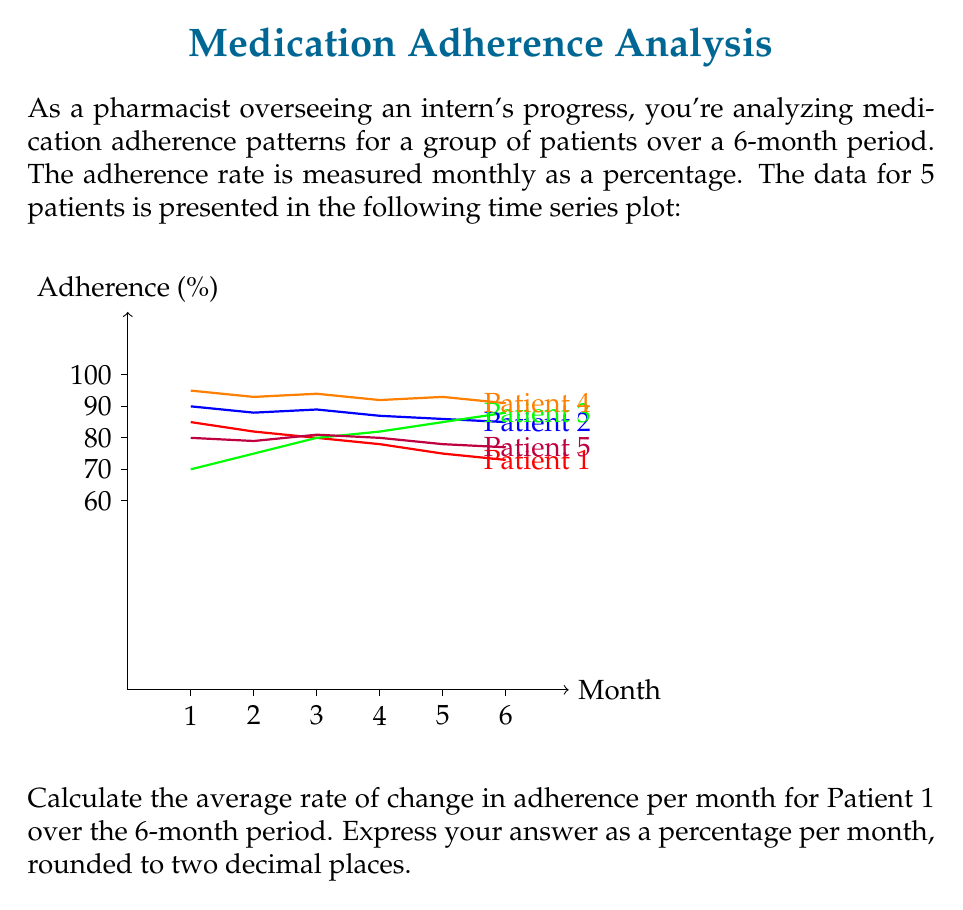Can you answer this question? To calculate the average rate of change in adherence per month for Patient 1, we need to follow these steps:

1. Identify the initial and final adherence rates for Patient 1:
   Initial rate (Month 1): 85%
   Final rate (Month 6): 73%

2. Calculate the total change in adherence:
   Total change = Final rate - Initial rate
   $\Delta y = 73\% - 85\% = -12\%$

3. Determine the time period:
   The data spans 6 months, so $\Delta x = 6$ months

4. Calculate the average rate of change using the formula:
   Average rate of change = $\frac{\text{Total change}}{\text{Time period}}$

   $\text{Average rate of change} = \frac{\Delta y}{\Delta x} = \frac{-12\%}{6\text{ months}} = -2\%\text{ per month}$

5. Round the result to two decimal places:
   $-2.00\%\text{ per month}$

The negative value indicates that the adherence rate is decreasing over time.
Answer: $-2.00\%\text{ per month}$ 